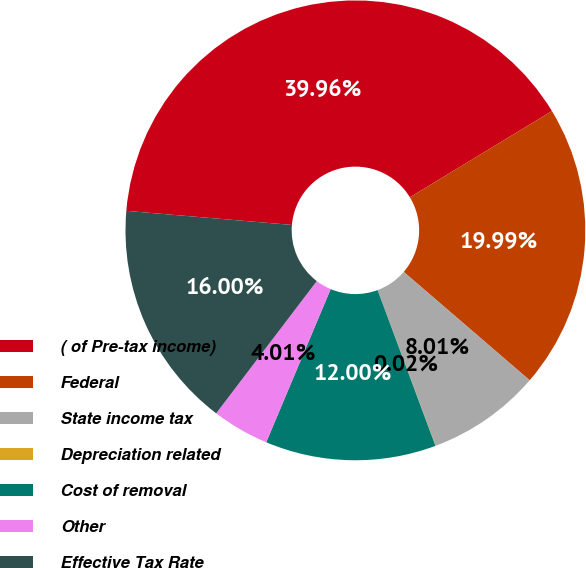Convert chart to OTSL. <chart><loc_0><loc_0><loc_500><loc_500><pie_chart><fcel>( of Pre-tax income)<fcel>Federal<fcel>State income tax<fcel>Depreciation related<fcel>Cost of removal<fcel>Other<fcel>Effective Tax Rate<nl><fcel>39.96%<fcel>19.99%<fcel>8.01%<fcel>0.02%<fcel>12.0%<fcel>4.01%<fcel>16.0%<nl></chart> 